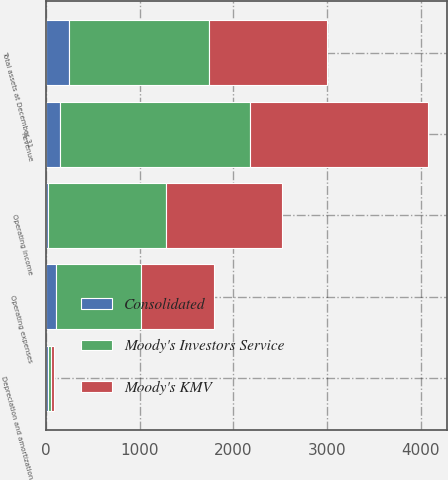Convert chart to OTSL. <chart><loc_0><loc_0><loc_500><loc_500><stacked_bar_chart><ecel><fcel>Revenue<fcel>Operating expenses<fcel>Depreciation and amortization<fcel>Operating income<fcel>Total assets at December 31<nl><fcel>Moody's KMV<fcel>1894.3<fcel>789.1<fcel>22.9<fcel>1242.9<fcel>1255.8<nl><fcel>Consolidated<fcel>142.8<fcel>109.6<fcel>16.6<fcel>16.6<fcel>241.9<nl><fcel>Moody's Investors Service<fcel>2037.1<fcel>898.7<fcel>39.5<fcel>1259.5<fcel>1497.7<nl></chart> 